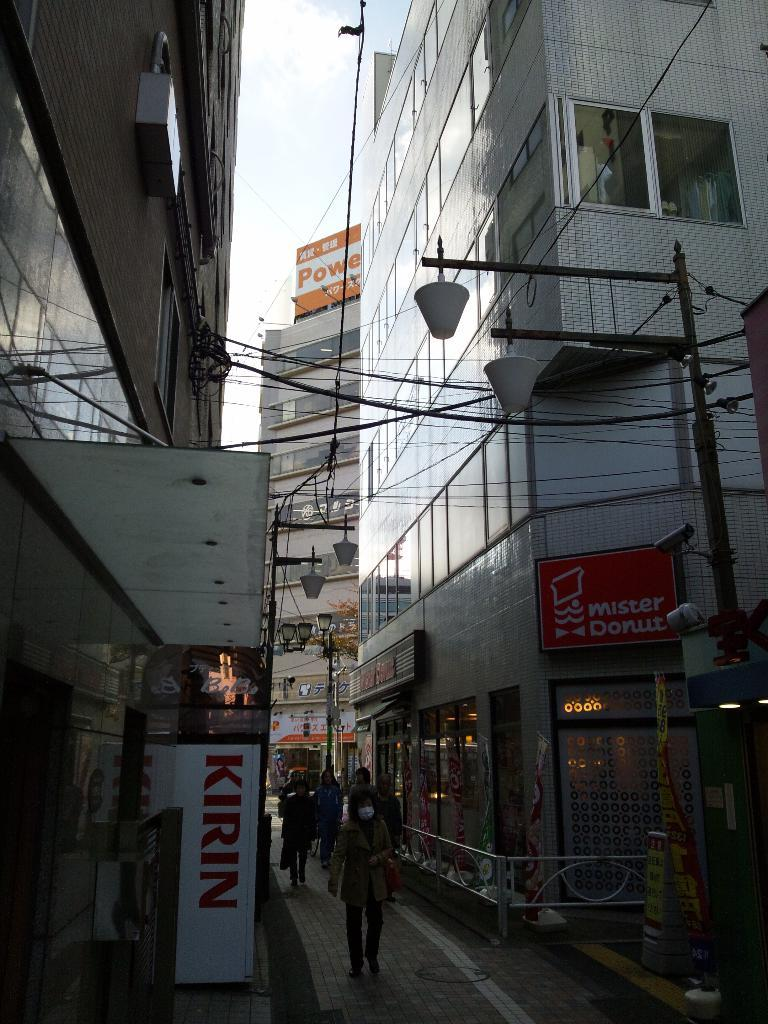What is the main setting of the image? The image depicts a street. What are the people in the image doing? People are walking on the street. What type of structures can be seen along the street? There are buildings with hoardings visible. What else can be seen along the street? There are poles with lights present. What type of lettuce is being sold at the produce stand in the image? There is no produce stand or lettuce present in the image. What news headline is displayed on the hoardings in the image? The hoardings in the image do not display any news headlines; they are advertisements for various products or services. 